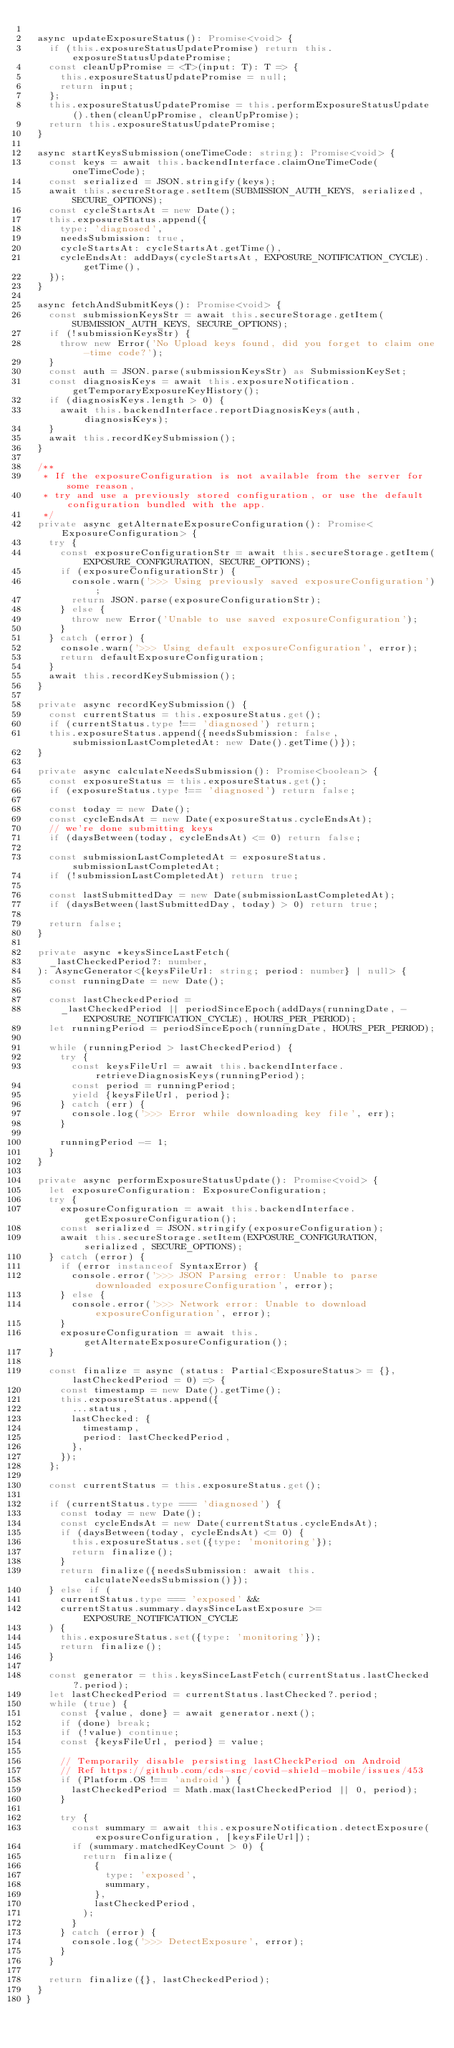Convert code to text. <code><loc_0><loc_0><loc_500><loc_500><_TypeScript_>
  async updateExposureStatus(): Promise<void> {
    if (this.exposureStatusUpdatePromise) return this.exposureStatusUpdatePromise;
    const cleanUpPromise = <T>(input: T): T => {
      this.exposureStatusUpdatePromise = null;
      return input;
    };
    this.exposureStatusUpdatePromise = this.performExposureStatusUpdate().then(cleanUpPromise, cleanUpPromise);
    return this.exposureStatusUpdatePromise;
  }

  async startKeysSubmission(oneTimeCode: string): Promise<void> {
    const keys = await this.backendInterface.claimOneTimeCode(oneTimeCode);
    const serialized = JSON.stringify(keys);
    await this.secureStorage.setItem(SUBMISSION_AUTH_KEYS, serialized, SECURE_OPTIONS);
    const cycleStartsAt = new Date();
    this.exposureStatus.append({
      type: 'diagnosed',
      needsSubmission: true,
      cycleStartsAt: cycleStartsAt.getTime(),
      cycleEndsAt: addDays(cycleStartsAt, EXPOSURE_NOTIFICATION_CYCLE).getTime(),
    });
  }

  async fetchAndSubmitKeys(): Promise<void> {
    const submissionKeysStr = await this.secureStorage.getItem(SUBMISSION_AUTH_KEYS, SECURE_OPTIONS);
    if (!submissionKeysStr) {
      throw new Error('No Upload keys found, did you forget to claim one-time code?');
    }
    const auth = JSON.parse(submissionKeysStr) as SubmissionKeySet;
    const diagnosisKeys = await this.exposureNotification.getTemporaryExposureKeyHistory();
    if (diagnosisKeys.length > 0) {
      await this.backendInterface.reportDiagnosisKeys(auth, diagnosisKeys);
    }
    await this.recordKeySubmission();
  }

  /**
   * If the exposureConfiguration is not available from the server for some reason,
   * try and use a previously stored configuration, or use the default configuration bundled with the app.
   */
  private async getAlternateExposureConfiguration(): Promise<ExposureConfiguration> {
    try {
      const exposureConfigurationStr = await this.secureStorage.getItem(EXPOSURE_CONFIGURATION, SECURE_OPTIONS);
      if (exposureConfigurationStr) {
        console.warn('>>> Using previously saved exposureConfiguration');
        return JSON.parse(exposureConfigurationStr);
      } else {
        throw new Error('Unable to use saved exposureConfiguration');
      }
    } catch (error) {
      console.warn('>>> Using default exposureConfiguration', error);
      return defaultExposureConfiguration;
    }
    await this.recordKeySubmission();
  }

  private async recordKeySubmission() {
    const currentStatus = this.exposureStatus.get();
    if (currentStatus.type !== 'diagnosed') return;
    this.exposureStatus.append({needsSubmission: false, submissionLastCompletedAt: new Date().getTime()});
  }

  private async calculateNeedsSubmission(): Promise<boolean> {
    const exposureStatus = this.exposureStatus.get();
    if (exposureStatus.type !== 'diagnosed') return false;

    const today = new Date();
    const cycleEndsAt = new Date(exposureStatus.cycleEndsAt);
    // we're done submitting keys
    if (daysBetween(today, cycleEndsAt) <= 0) return false;

    const submissionLastCompletedAt = exposureStatus.submissionLastCompletedAt;
    if (!submissionLastCompletedAt) return true;

    const lastSubmittedDay = new Date(submissionLastCompletedAt);
    if (daysBetween(lastSubmittedDay, today) > 0) return true;

    return false;
  }

  private async *keysSinceLastFetch(
    _lastCheckedPeriod?: number,
  ): AsyncGenerator<{keysFileUrl: string; period: number} | null> {
    const runningDate = new Date();

    const lastCheckedPeriod =
      _lastCheckedPeriod || periodSinceEpoch(addDays(runningDate, -EXPOSURE_NOTIFICATION_CYCLE), HOURS_PER_PERIOD);
    let runningPeriod = periodSinceEpoch(runningDate, HOURS_PER_PERIOD);

    while (runningPeriod > lastCheckedPeriod) {
      try {
        const keysFileUrl = await this.backendInterface.retrieveDiagnosisKeys(runningPeriod);
        const period = runningPeriod;
        yield {keysFileUrl, period};
      } catch (err) {
        console.log('>>> Error while downloading key file', err);
      }

      runningPeriod -= 1;
    }
  }

  private async performExposureStatusUpdate(): Promise<void> {
    let exposureConfiguration: ExposureConfiguration;
    try {
      exposureConfiguration = await this.backendInterface.getExposureConfiguration();
      const serialized = JSON.stringify(exposureConfiguration);
      await this.secureStorage.setItem(EXPOSURE_CONFIGURATION, serialized, SECURE_OPTIONS);
    } catch (error) {
      if (error instanceof SyntaxError) {
        console.error('>>> JSON Parsing error: Unable to parse downloaded exposureConfiguration', error);
      } else {
        console.error('>>> Network error: Unable to download exposureConfiguration', error);
      }
      exposureConfiguration = await this.getAlternateExposureConfiguration();
    }

    const finalize = async (status: Partial<ExposureStatus> = {}, lastCheckedPeriod = 0) => {
      const timestamp = new Date().getTime();
      this.exposureStatus.append({
        ...status,
        lastChecked: {
          timestamp,
          period: lastCheckedPeriod,
        },
      });
    };

    const currentStatus = this.exposureStatus.get();

    if (currentStatus.type === 'diagnosed') {
      const today = new Date();
      const cycleEndsAt = new Date(currentStatus.cycleEndsAt);
      if (daysBetween(today, cycleEndsAt) <= 0) {
        this.exposureStatus.set({type: 'monitoring'});
        return finalize();
      }
      return finalize({needsSubmission: await this.calculateNeedsSubmission()});
    } else if (
      currentStatus.type === 'exposed' &&
      currentStatus.summary.daysSinceLastExposure >= EXPOSURE_NOTIFICATION_CYCLE
    ) {
      this.exposureStatus.set({type: 'monitoring'});
      return finalize();
    }

    const generator = this.keysSinceLastFetch(currentStatus.lastChecked?.period);
    let lastCheckedPeriod = currentStatus.lastChecked?.period;
    while (true) {
      const {value, done} = await generator.next();
      if (done) break;
      if (!value) continue;
      const {keysFileUrl, period} = value;

      // Temporarily disable persisting lastCheckPeriod on Android
      // Ref https://github.com/cds-snc/covid-shield-mobile/issues/453
      if (Platform.OS !== 'android') {
        lastCheckedPeriod = Math.max(lastCheckedPeriod || 0, period);
      }

      try {
        const summary = await this.exposureNotification.detectExposure(exposureConfiguration, [keysFileUrl]);
        if (summary.matchedKeyCount > 0) {
          return finalize(
            {
              type: 'exposed',
              summary,
            },
            lastCheckedPeriod,
          );
        }
      } catch (error) {
        console.log('>>> DetectExposure', error);
      }
    }

    return finalize({}, lastCheckedPeriod);
  }
}
</code> 